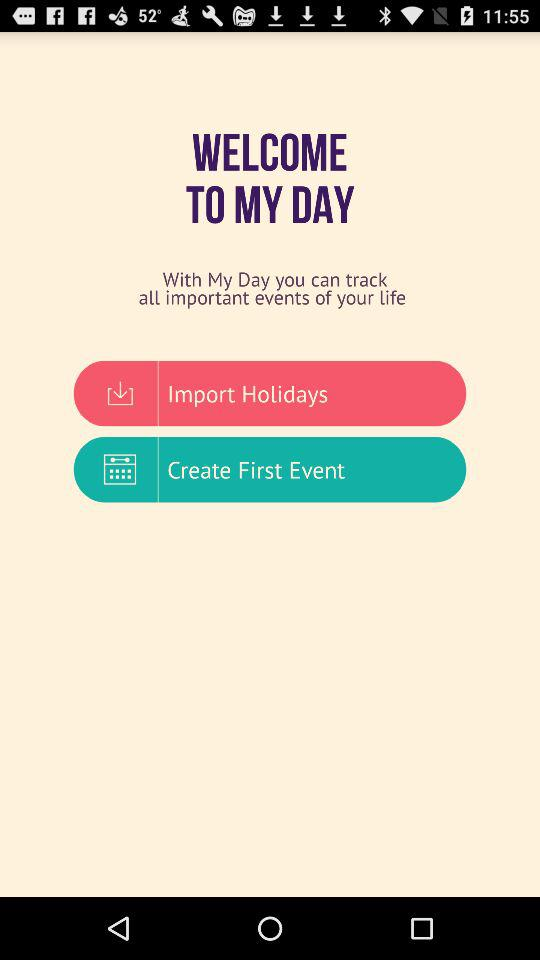What is the name of the application? The name of the application is "MY DAY". 